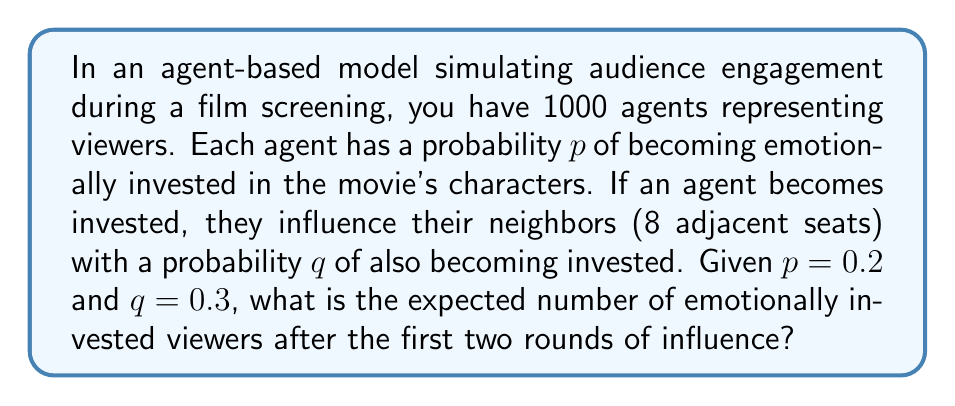Can you answer this question? Let's approach this step-by-step:

1. Initial round:
   - Number of initially invested viewers: $1000 \times p = 1000 \times 0.2 = 200$

2. Second round (influence):
   - Each invested viewer can influence 8 neighbors
   - Probability of influencing each neighbor: $q = 0.3$
   - Expected number of new invested viewers per initial investor:
     $8 \times q = 8 \times 0.3 = 2.4$
   
3. Total new investors from second round:
   $200 \times 2.4 = 480$

4. However, some of these might overlap with initially invested viewers or each other. We need to calculate the probability of a viewer not being invested after two rounds:
   - Probability of not being initially invested: $1 - p = 0.8$
   - Probability of not being influenced by any of the 8 neighbors:
     $(1 - q)^8 = 0.7^8 \approx 0.0582$

5. Probability of a viewer being invested after two rounds:
   $1 - (0.8 \times 0.0582) \approx 0.9534$

6. Expected number of invested viewers after two rounds:
   $1000 \times 0.9534 \approx 953.4$
Answer: 953 